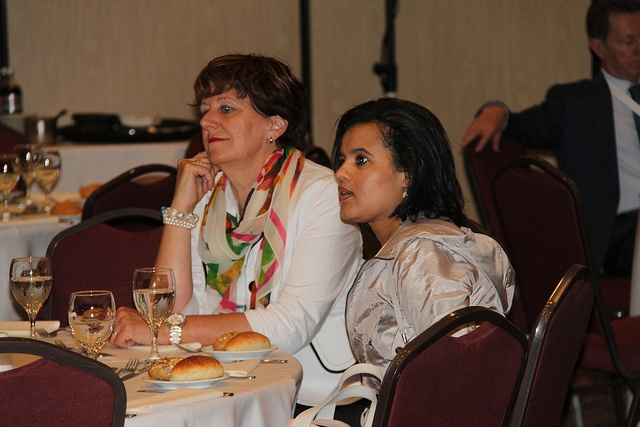Describe the objects in this image and their specific colors. I can see people in black, darkgray, and salmon tones, people in black, darkgray, gray, and brown tones, people in black, maroon, and gray tones, chair in black, maroon, darkgray, and gray tones, and chair in black, maroon, and brown tones in this image. 